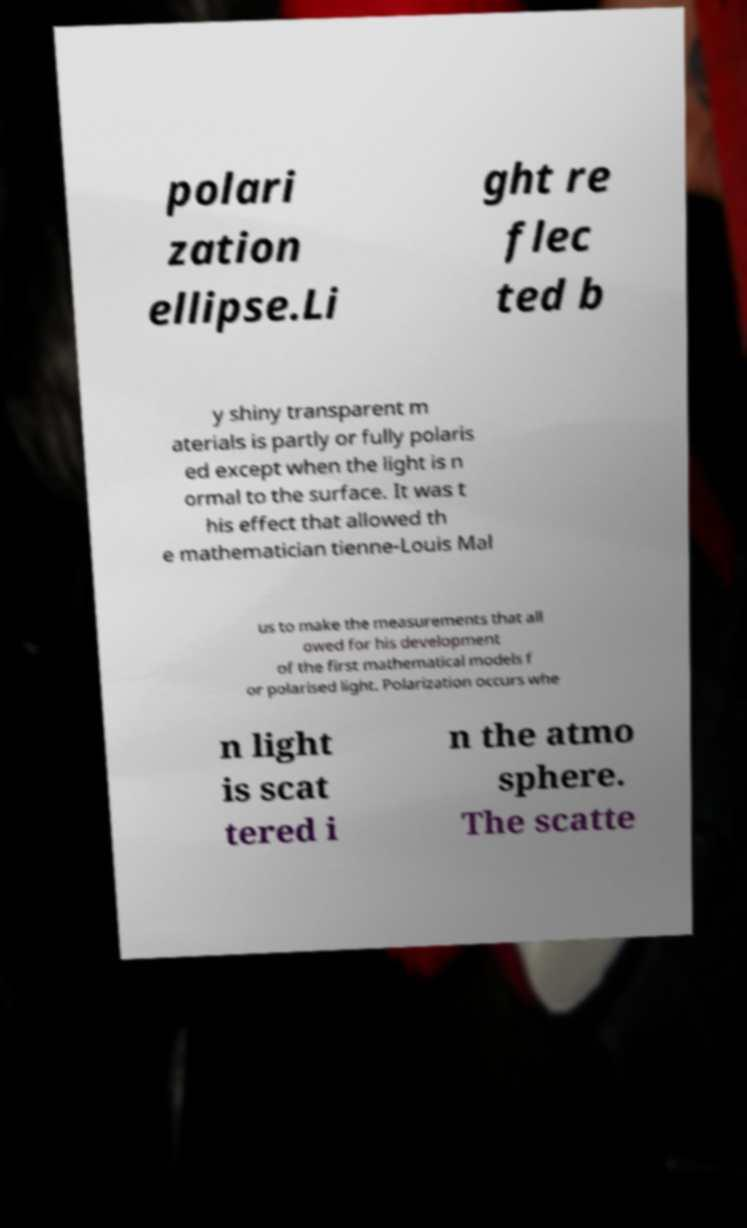Please identify and transcribe the text found in this image. polari zation ellipse.Li ght re flec ted b y shiny transparent m aterials is partly or fully polaris ed except when the light is n ormal to the surface. It was t his effect that allowed th e mathematician tienne-Louis Mal us to make the measurements that all owed for his development of the first mathematical models f or polarised light. Polarization occurs whe n light is scat tered i n the atmo sphere. The scatte 